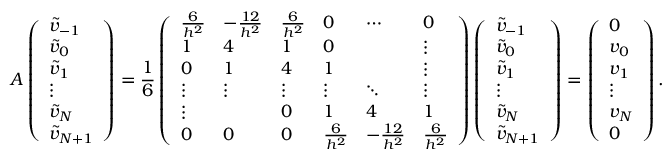<formula> <loc_0><loc_0><loc_500><loc_500>A \left ( \begin{array} { l } { \widetilde { v } _ { - 1 } } \\ { \widetilde { v } _ { 0 } } \\ { \widetilde { v } _ { 1 } } \\ { \vdots } \\ { \widetilde { v } _ { N } } \\ { \widetilde { v } _ { N + 1 } } \end{array} \right ) = \frac { 1 } { 6 } \left ( \begin{array} { l l l l l l } { \frac { 6 } { h ^ { 2 } } } & { - \frac { 1 2 } { h ^ { 2 } } } & { \frac { 6 } { h ^ { 2 } } } & { 0 } & { \cdots } & { 0 } \\ { 1 } & { 4 } & { 1 } & { 0 } & & { \vdots } \\ { 0 } & { 1 } & { 4 } & { 1 } & & { \vdots } \\ { \vdots } & { \vdots } & { \vdots } & { \vdots } & { \ddots } & { \vdots } \\ { \vdots } & & { 0 } & { 1 } & { 4 } & { 1 } \\ { 0 } & { 0 } & { 0 } & { \frac { 6 } { h ^ { 2 } } } & { - \frac { 1 2 } { h ^ { 2 } } } & { \frac { 6 } { h ^ { 2 } } } \end{array} \right ) \left ( \begin{array} { l } { \widetilde { v } _ { - 1 } } \\ { \widetilde { v } _ { 0 } } \\ { \widetilde { v } _ { 1 } } \\ { \vdots } \\ { \widetilde { v } _ { N } } \\ { \widetilde { v } _ { N + 1 } } \end{array} \right ) = \left ( \begin{array} { l } { 0 } \\ { v _ { 0 } } \\ { v _ { 1 } } \\ { \vdots } \\ { v _ { N } } \\ { 0 } \end{array} \right ) .</formula> 